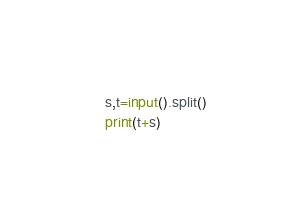<code> <loc_0><loc_0><loc_500><loc_500><_Python_>s,t=input().split()
print(t+s)</code> 